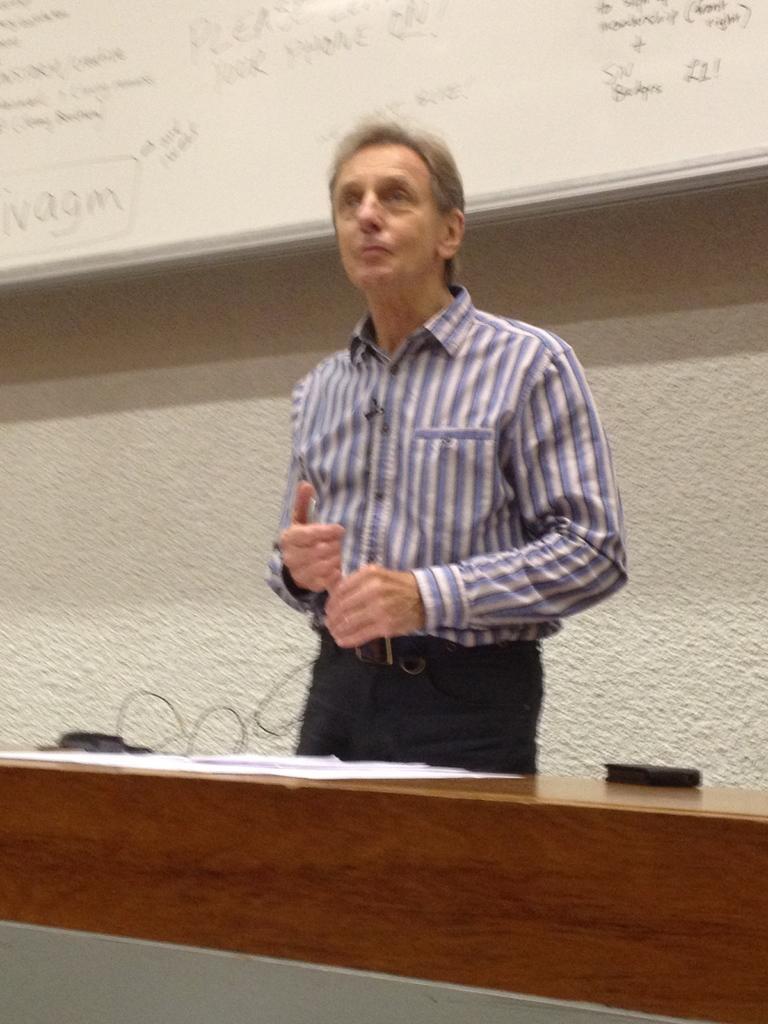Please provide a concise description of this image. In the center of this picture we can see a person wearing shirt and standing and we can see there are some objects placed on the top of a wooden object seems to be the table. In the background we can see the wall and we can see the text on a white color board. 